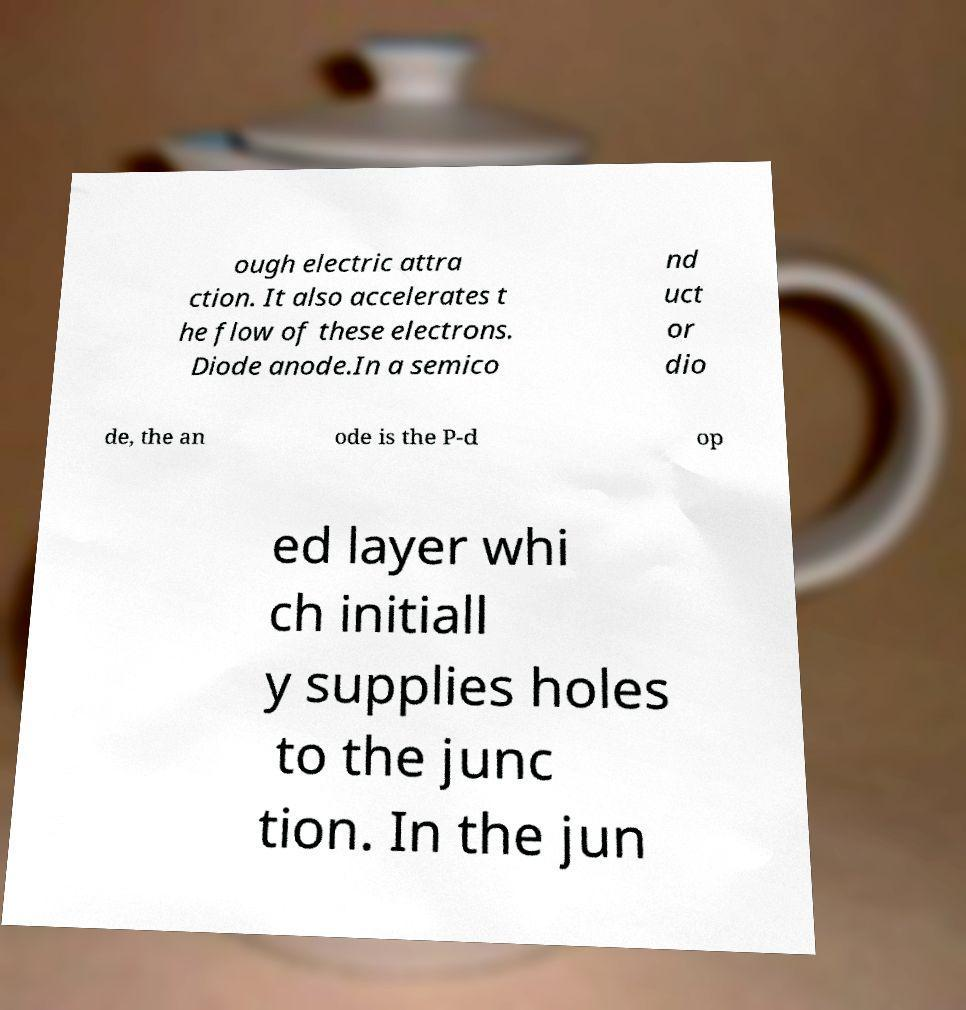Please identify and transcribe the text found in this image. ough electric attra ction. It also accelerates t he flow of these electrons. Diode anode.In a semico nd uct or dio de, the an ode is the P-d op ed layer whi ch initiall y supplies holes to the junc tion. In the jun 